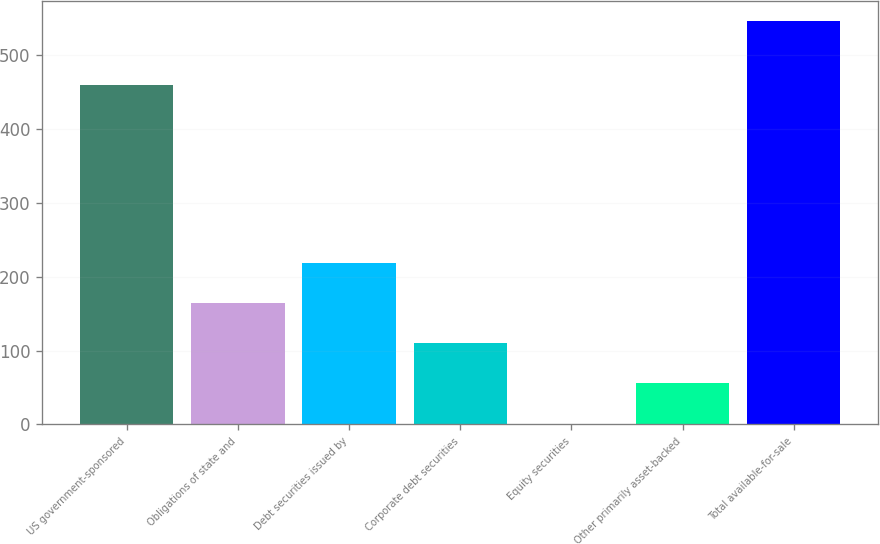Convert chart. <chart><loc_0><loc_0><loc_500><loc_500><bar_chart><fcel>US government-sponsored<fcel>Obligations of state and<fcel>Debt securities issued by<fcel>Corporate debt securities<fcel>Equity securities<fcel>Other primarily asset-backed<fcel>Total available-for-sale<nl><fcel>460<fcel>164.5<fcel>219<fcel>110<fcel>1<fcel>55.5<fcel>546<nl></chart> 